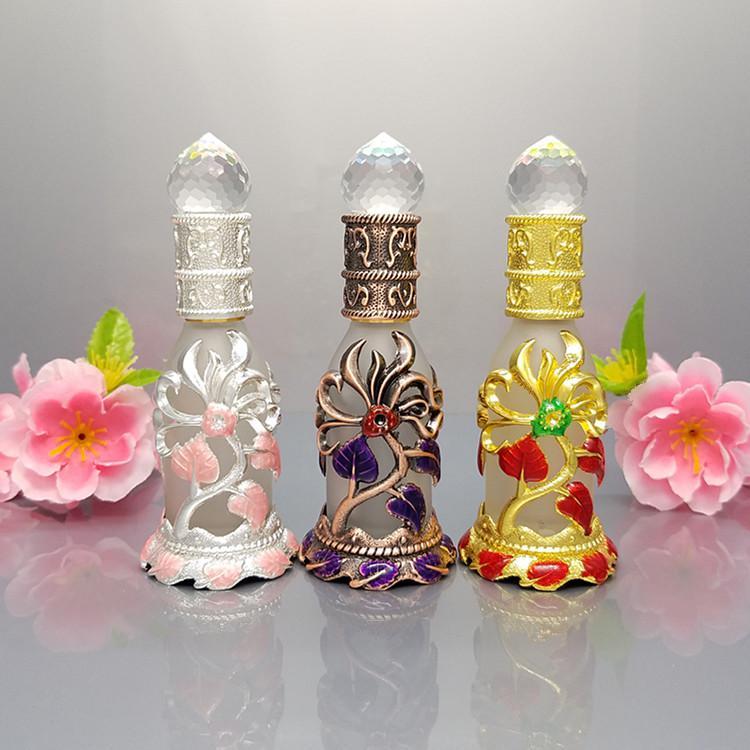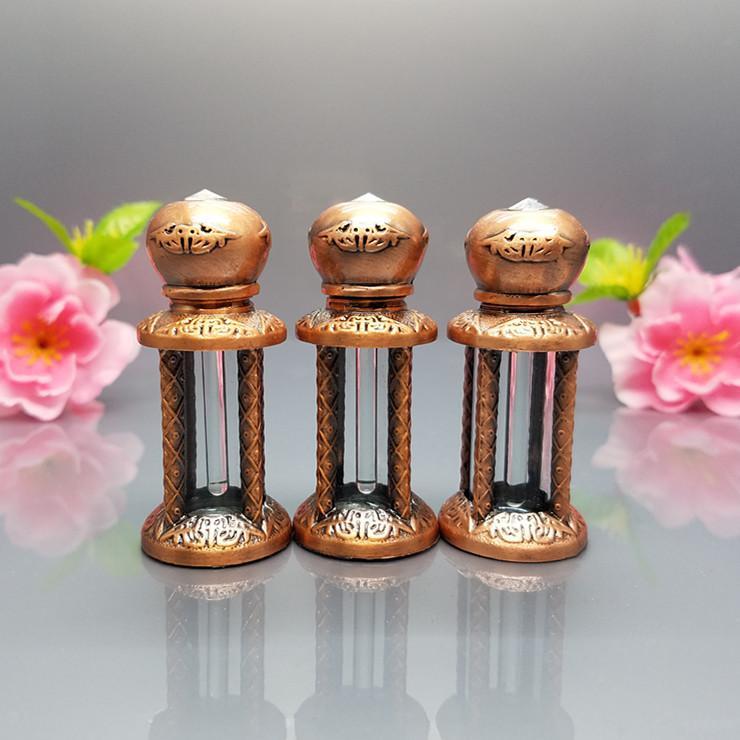The first image is the image on the left, the second image is the image on the right. Examine the images to the left and right. Is the description "There are two containers in one of the images." accurate? Answer yes or no. No. The first image is the image on the left, the second image is the image on the right. Analyze the images presented: Is the assertion "An image shows at least two decorative bottles flanked by flowers, and the bottles feature different metallic colors partly wrapping semi-translucent glass." valid? Answer yes or no. Yes. 